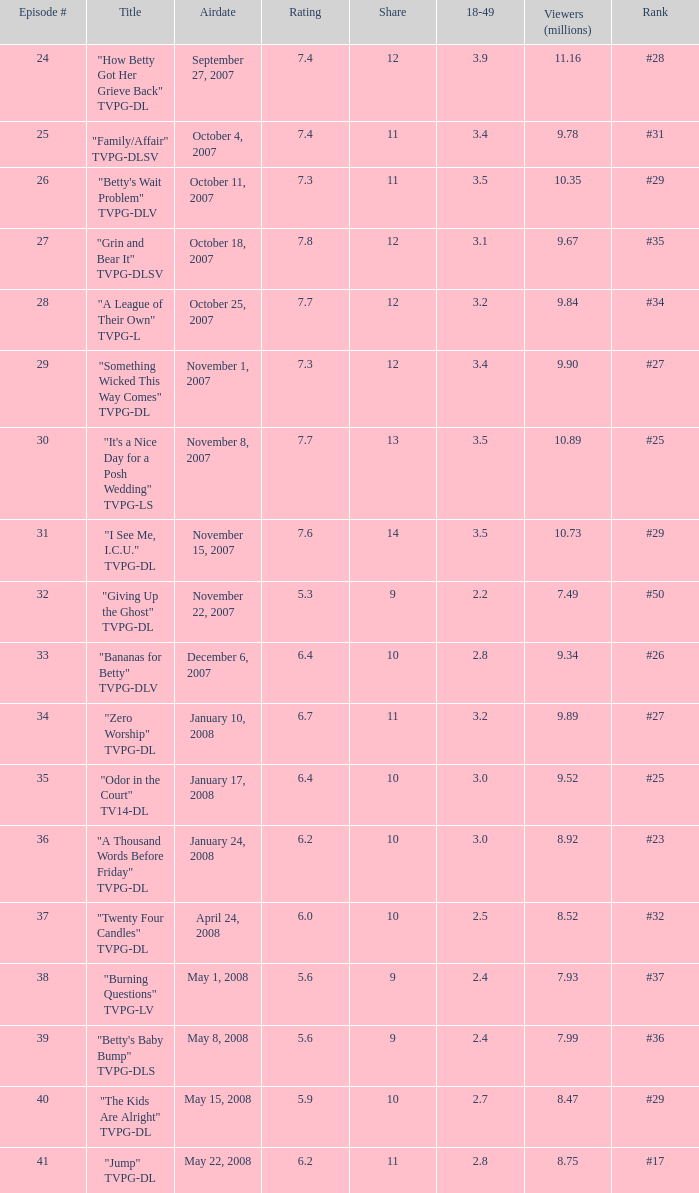What is the Airdate of the episode that ranked #29 and had a share greater than 10? May 15, 2008. 